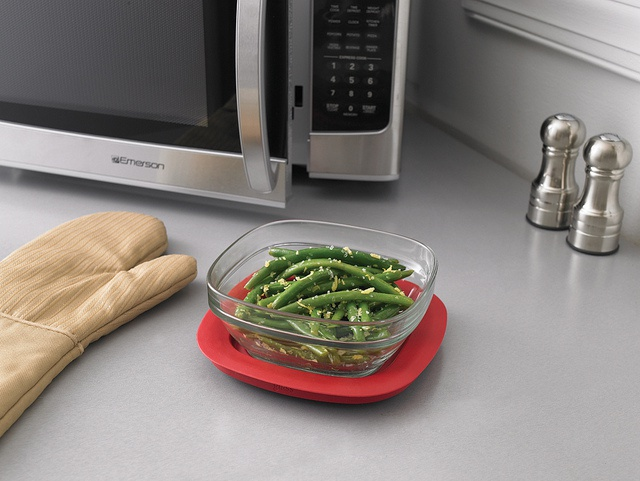Describe the objects in this image and their specific colors. I can see microwave in gray, black, darkgray, and lightgray tones and bowl in gray, darkgray, darkgreen, and black tones in this image. 